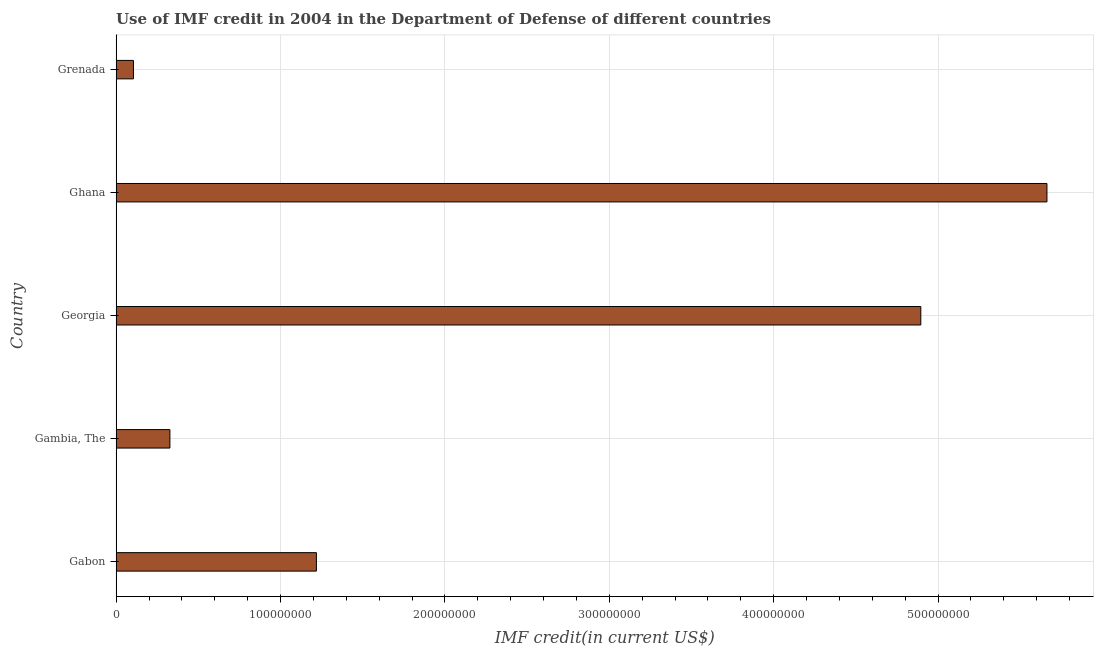Does the graph contain grids?
Provide a short and direct response. Yes. What is the title of the graph?
Provide a succinct answer. Use of IMF credit in 2004 in the Department of Defense of different countries. What is the label or title of the X-axis?
Your answer should be very brief. IMF credit(in current US$). What is the use of imf credit in dod in Gabon?
Offer a very short reply. 1.22e+08. Across all countries, what is the maximum use of imf credit in dod?
Give a very brief answer. 5.66e+08. Across all countries, what is the minimum use of imf credit in dod?
Offer a terse response. 1.05e+07. In which country was the use of imf credit in dod maximum?
Your response must be concise. Ghana. In which country was the use of imf credit in dod minimum?
Keep it short and to the point. Grenada. What is the sum of the use of imf credit in dod?
Keep it short and to the point. 1.22e+09. What is the difference between the use of imf credit in dod in Gambia, The and Georgia?
Keep it short and to the point. -4.57e+08. What is the average use of imf credit in dod per country?
Give a very brief answer. 2.44e+08. What is the median use of imf credit in dod?
Offer a very short reply. 1.22e+08. In how many countries, is the use of imf credit in dod greater than 100000000 US$?
Ensure brevity in your answer.  3. What is the ratio of the use of imf credit in dod in Georgia to that in Grenada?
Your response must be concise. 46.46. What is the difference between the highest and the second highest use of imf credit in dod?
Keep it short and to the point. 7.67e+07. What is the difference between the highest and the lowest use of imf credit in dod?
Keep it short and to the point. 5.56e+08. Are all the bars in the graph horizontal?
Your response must be concise. Yes. How many countries are there in the graph?
Provide a succinct answer. 5. What is the difference between two consecutive major ticks on the X-axis?
Keep it short and to the point. 1.00e+08. What is the IMF credit(in current US$) of Gabon?
Give a very brief answer. 1.22e+08. What is the IMF credit(in current US$) of Gambia, The?
Keep it short and to the point. 3.27e+07. What is the IMF credit(in current US$) in Georgia?
Offer a terse response. 4.90e+08. What is the IMF credit(in current US$) in Ghana?
Your answer should be very brief. 5.66e+08. What is the IMF credit(in current US$) in Grenada?
Your answer should be very brief. 1.05e+07. What is the difference between the IMF credit(in current US$) in Gabon and Gambia, The?
Ensure brevity in your answer.  8.91e+07. What is the difference between the IMF credit(in current US$) in Gabon and Georgia?
Your answer should be compact. -3.68e+08. What is the difference between the IMF credit(in current US$) in Gabon and Ghana?
Keep it short and to the point. -4.44e+08. What is the difference between the IMF credit(in current US$) in Gabon and Grenada?
Provide a short and direct response. 1.11e+08. What is the difference between the IMF credit(in current US$) in Gambia, The and Georgia?
Give a very brief answer. -4.57e+08. What is the difference between the IMF credit(in current US$) in Gambia, The and Ghana?
Your response must be concise. -5.34e+08. What is the difference between the IMF credit(in current US$) in Gambia, The and Grenada?
Your answer should be very brief. 2.22e+07. What is the difference between the IMF credit(in current US$) in Georgia and Ghana?
Give a very brief answer. -7.67e+07. What is the difference between the IMF credit(in current US$) in Georgia and Grenada?
Your answer should be very brief. 4.79e+08. What is the difference between the IMF credit(in current US$) in Ghana and Grenada?
Provide a succinct answer. 5.56e+08. What is the ratio of the IMF credit(in current US$) in Gabon to that in Gambia, The?
Provide a succinct answer. 3.72. What is the ratio of the IMF credit(in current US$) in Gabon to that in Georgia?
Make the answer very short. 0.25. What is the ratio of the IMF credit(in current US$) in Gabon to that in Ghana?
Your answer should be compact. 0.21. What is the ratio of the IMF credit(in current US$) in Gabon to that in Grenada?
Make the answer very short. 11.56. What is the ratio of the IMF credit(in current US$) in Gambia, The to that in Georgia?
Give a very brief answer. 0.07. What is the ratio of the IMF credit(in current US$) in Gambia, The to that in Ghana?
Offer a terse response. 0.06. What is the ratio of the IMF credit(in current US$) in Gambia, The to that in Grenada?
Offer a terse response. 3.1. What is the ratio of the IMF credit(in current US$) in Georgia to that in Ghana?
Your response must be concise. 0.86. What is the ratio of the IMF credit(in current US$) in Georgia to that in Grenada?
Keep it short and to the point. 46.46. What is the ratio of the IMF credit(in current US$) in Ghana to that in Grenada?
Provide a succinct answer. 53.74. 